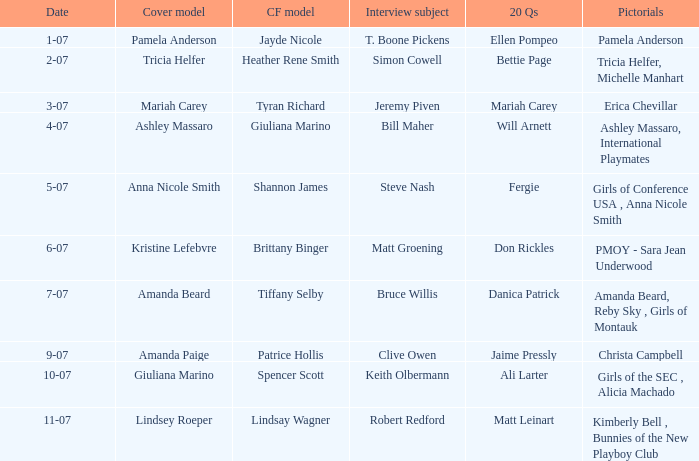Who was the cover model when the issue's pictorials was pmoy - sara jean underwood? Kristine Lefebvre. 